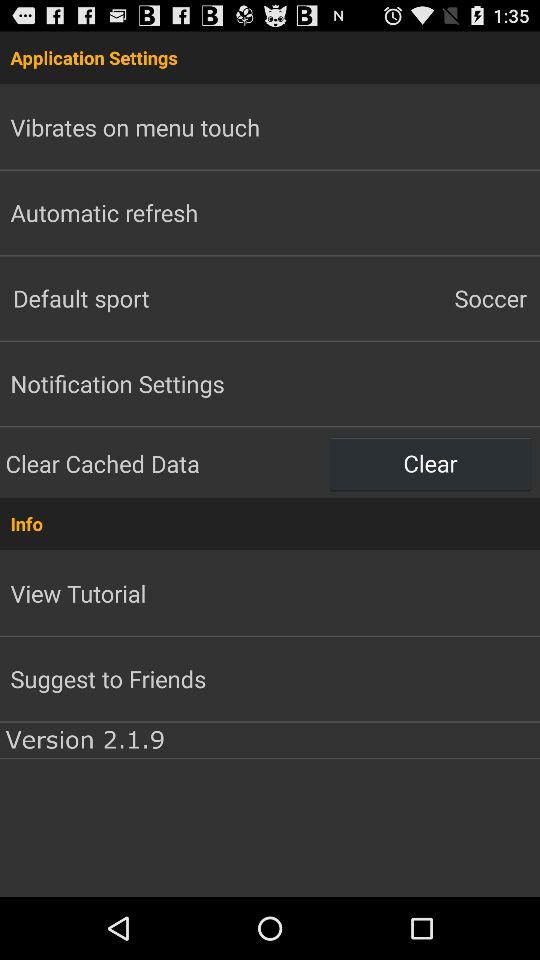What is the default sport? The default sport is soccer. 